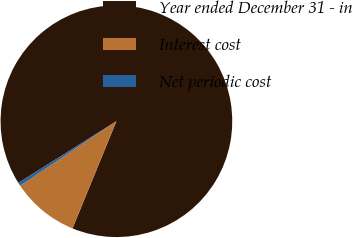Convert chart to OTSL. <chart><loc_0><loc_0><loc_500><loc_500><pie_chart><fcel>Year ended December 31 - in<fcel>Interest cost<fcel>Net periodic cost<nl><fcel>90.13%<fcel>9.42%<fcel>0.45%<nl></chart> 